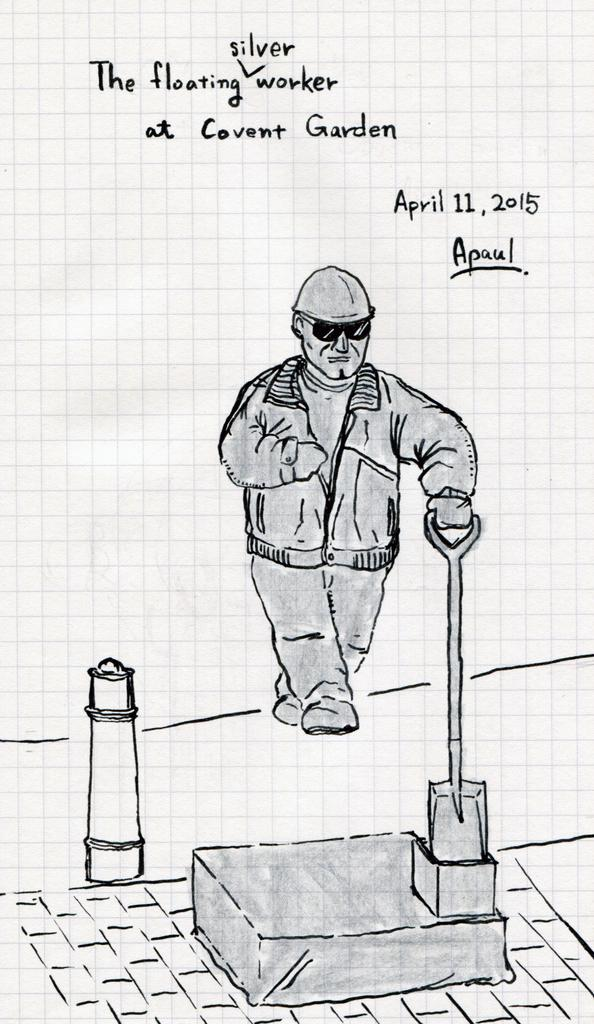What is depicted in the image? There is a sketch of a person in the image. What is the person in the sketch doing? The person is standing and holding an object in their hands. Are there any words present in the image? Yes, there are words written at the top of the image. What type of poison is the person in the sketch holding? There is no poison present in the image; the person is holding an object, but it is not specified as poison. Is there an arch visible in the image? There is no arch present in the image; the image only contains a sketch of a person and some written words. 